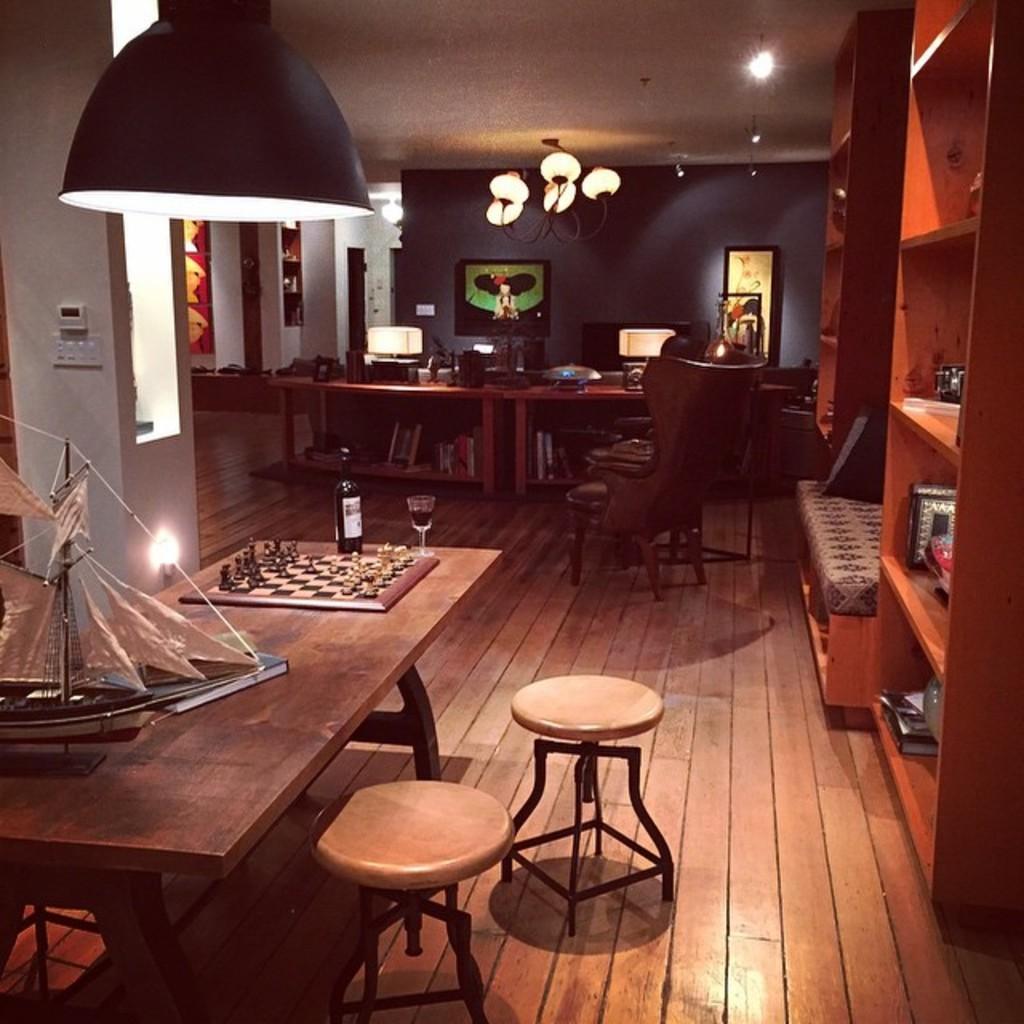Can you describe this image briefly? This is an inside view of a room. On the right side there is a cupboard in which few objects are placed. On the left side there is a table on which a chess board, bottle, a glass and some other objects are placed. Beside the table there are two stools. In the background there is another table on which many objects are placed. Under the table there are some books. There are some photo frames attached to the wall. At the top I can see some lights. 